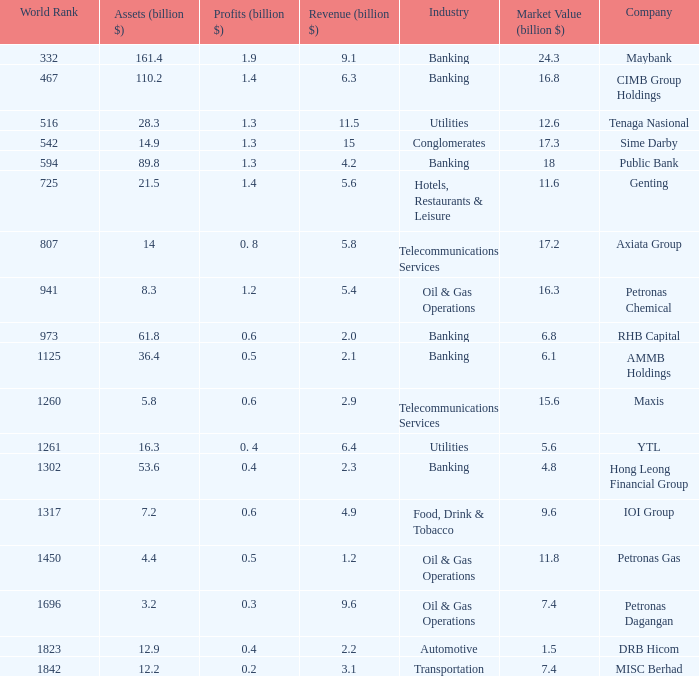Name the profits for market value of 11.8 0.5. 